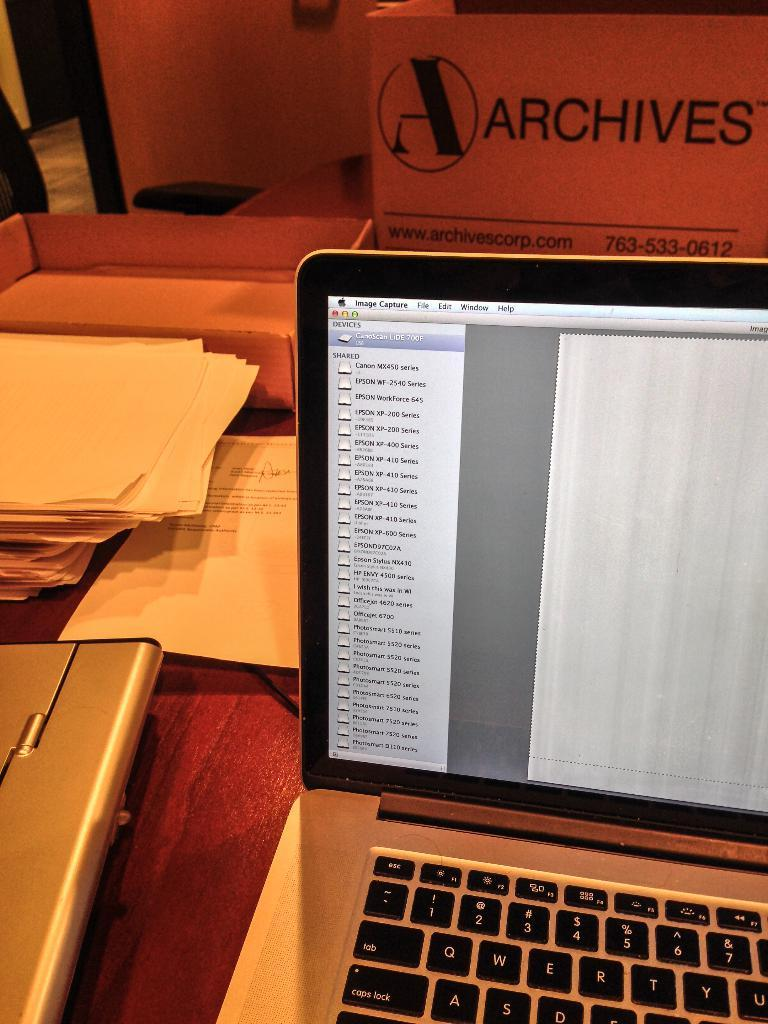<image>
Create a compact narrative representing the image presented. laptop that has apple image capture running and stack of papers and boxes behind it 